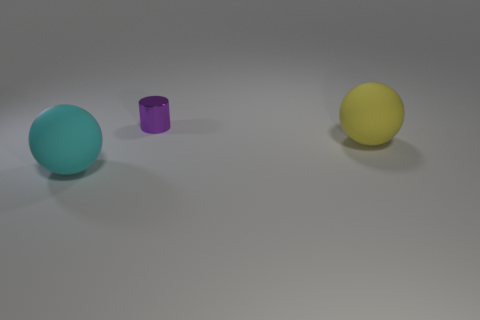Add 1 yellow rubber balls. How many objects exist? 4 Add 2 small brown metallic cubes. How many small brown metallic cubes exist? 2 Subtract 0 blue cubes. How many objects are left? 3 Subtract all cylinders. How many objects are left? 2 Subtract all small purple matte cylinders. Subtract all yellow things. How many objects are left? 2 Add 1 purple objects. How many purple objects are left? 2 